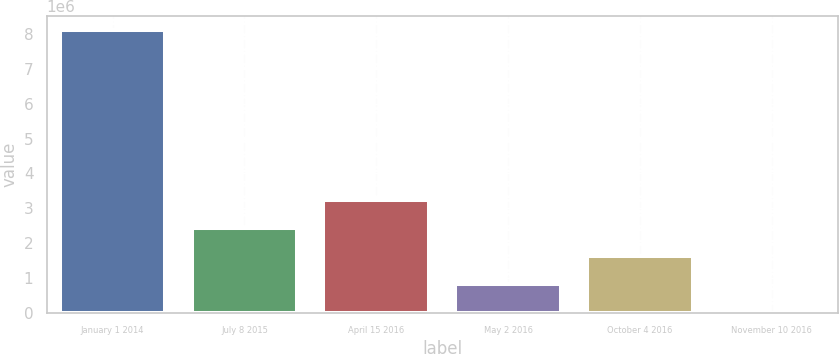Convert chart to OTSL. <chart><loc_0><loc_0><loc_500><loc_500><bar_chart><fcel>January 1 2014<fcel>July 8 2015<fcel>April 15 2016<fcel>May 2 2016<fcel>October 4 2016<fcel>November 10 2016<nl><fcel>8.1211e+06<fcel>2.43722e+06<fcel>3.2492e+06<fcel>813252<fcel>1.62524e+06<fcel>1269<nl></chart> 